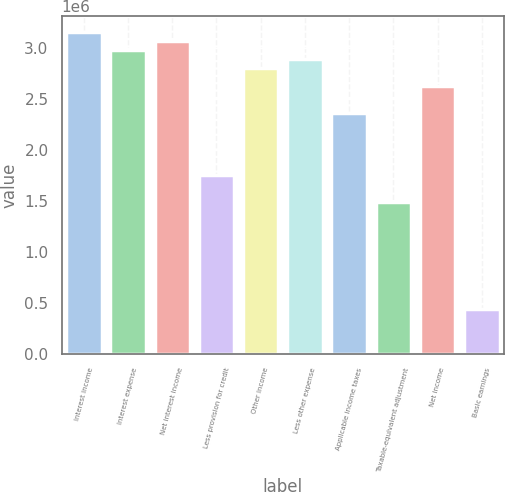<chart> <loc_0><loc_0><loc_500><loc_500><bar_chart><fcel>Interest income<fcel>Interest expense<fcel>Net interest income<fcel>Less provision for credit<fcel>Other income<fcel>Less other expense<fcel>Applicable income taxes<fcel>Taxable-equivalent adjustment<fcel>Net income<fcel>Basic earnings<nl><fcel>3.15431e+06<fcel>2.97907e+06<fcel>3.06669e+06<fcel>1.75239e+06<fcel>2.80383e+06<fcel>2.89145e+06<fcel>2.36573e+06<fcel>1.48953e+06<fcel>2.62859e+06<fcel>438099<nl></chart> 